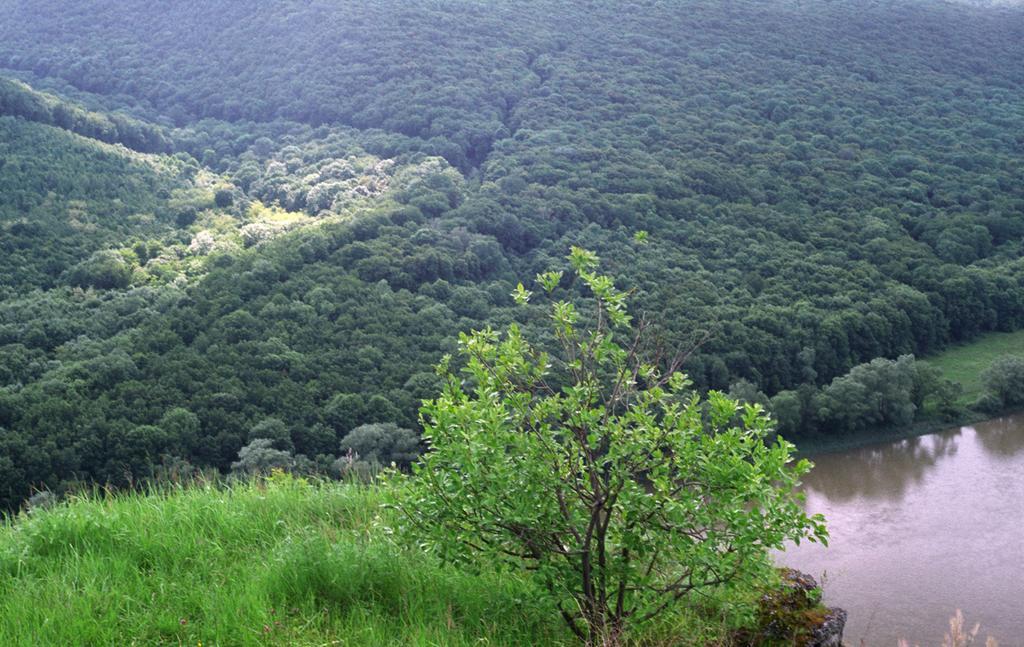How would you summarize this image in a sentence or two? This is an outside view. In the bottom right there is a river. At the bottom, I can see the grass and a plant. In the background there are many trees. 